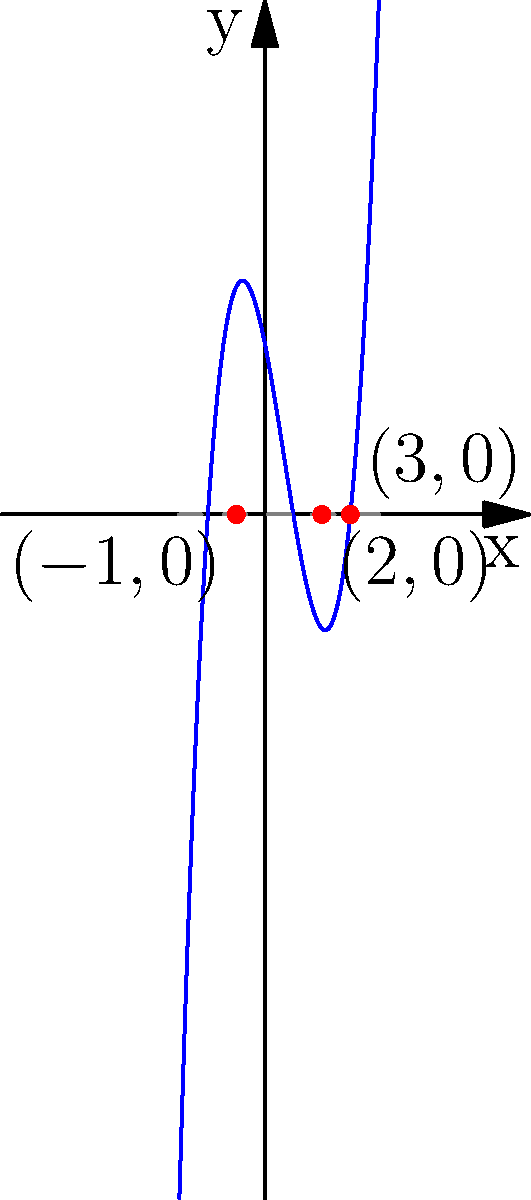The graph above represents a cubic polynomial function $f(x) = x^3 - 2x^2 - 5x + 6$. What are the roots of this polynomial, and what is their sum? To solve this problem, let's follow these steps:

1) First, we need to identify the roots of the polynomial from the graph. The roots are the x-intercepts, where the curve crosses the x-axis.

2) From the graph, we can see that the curve intersects the x-axis at three points:
   $x = -1$, $x = 2$, and $x = 3$

3) These x-intercepts are the roots of the polynomial. So, the roots are -1, 2, and 3.

4) To find the sum of the roots, we simply add these values:
   $-1 + 2 + 3 = 4$

5) We can verify this result using Vieta's formulas. For a cubic polynomial $ax^3 + bx^2 + cx + d$, the sum of the roots is equal to $-\frac{b}{a}$. In our case:

   $f(x) = x^3 - 2x^2 - 5x + 6$

   So, $a = 1$ and $b = -2$

   $-\frac{b}{a} = -\frac{-2}{1} = 2$

   This confirms our graphical solution.

Therefore, the roots of the polynomial are -1, 2, and 3, and their sum is 4.
Answer: Roots: -1, 2, 3; Sum: 4 